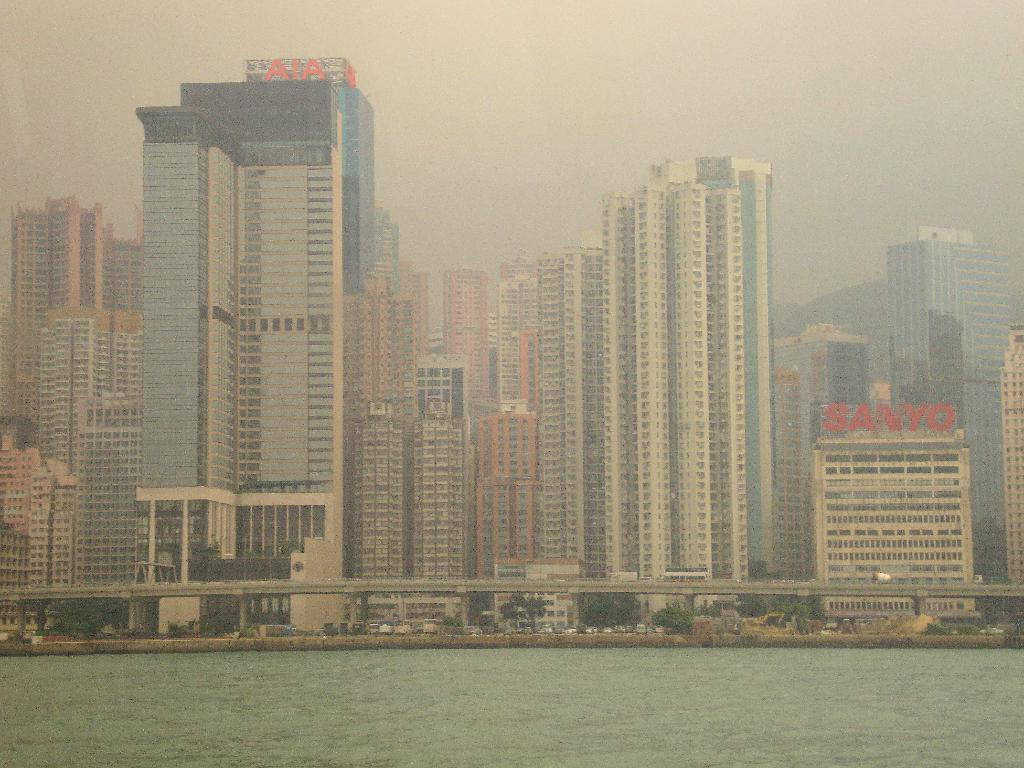What is the primary element in the image? There is water in the image. What can be seen in the distance behind the water? There are buildings visible in the background of the image. What is the color of the sky in the image? The sky is white in color. How many sheep are visible in the image? There are no sheep present in the image. What type of jeans are the buildings wearing in the image? Buildings do not wear jeans; they are inanimate structures. 